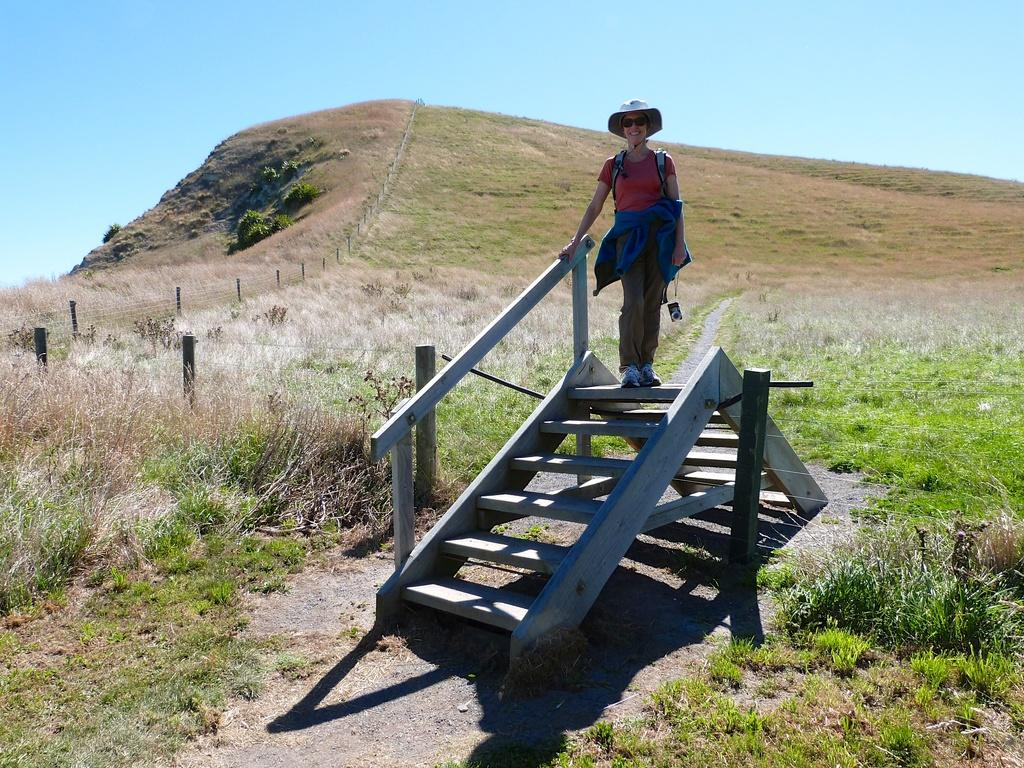What is the woman in the image doing? The woman is standing on the stairs in the image. What can be seen in the background of the image? There is fencing, a hill, trees, plants, grass, and the sky visible in the background of the image. Reasoning: Let's think step by step by step in order to produce the conversation. We start by identifying the main subject in the image, which is the woman standing on the stairs. Then, we expand the conversation to include the background elements of the image, which are described in detail in the provided facts. Each question is designed to elicit a specific detail about the image that is known from the provided facts. Absurd Question/Answer: What type of bomb is the woman holding in the image? There is no bomb present in the image; the woman is simply standing on the stairs. 